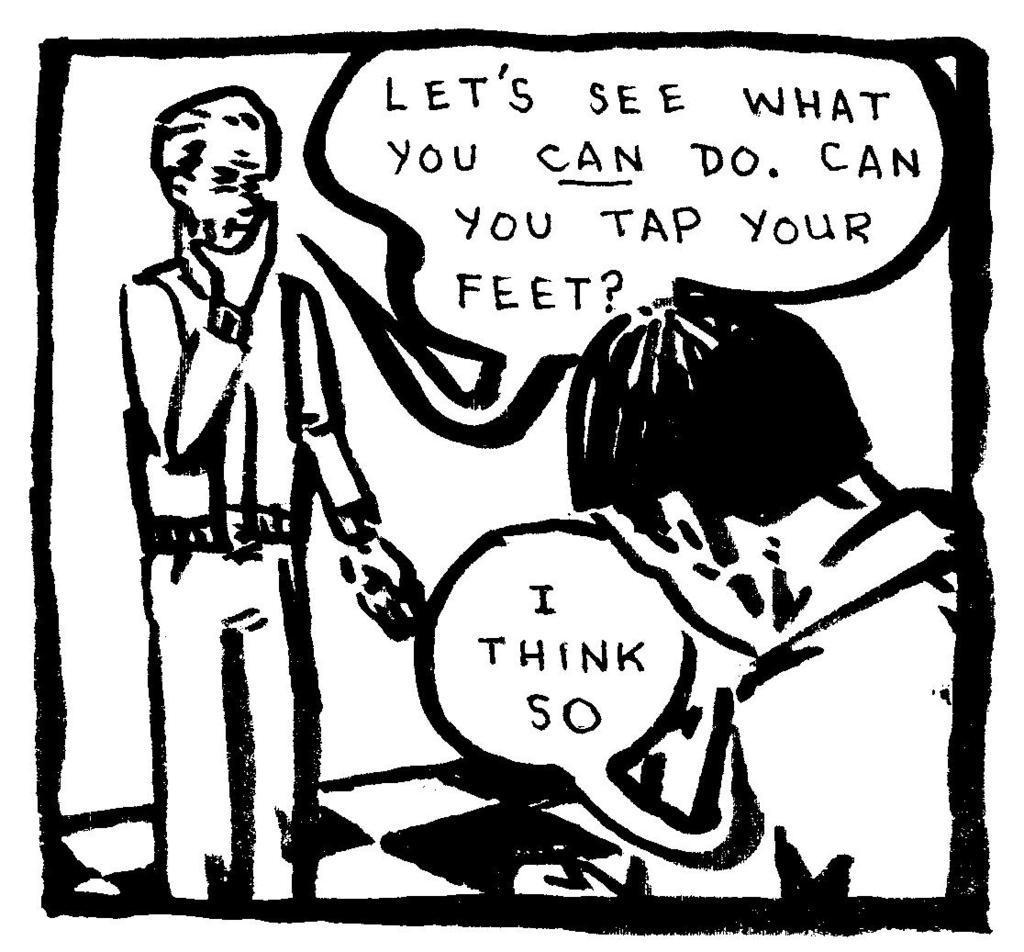How would you summarize this image in a sentence or two? In the picture I can see the image of a person standing and there is something written beside him and there is another person in the right corner and there is something written beside him. 